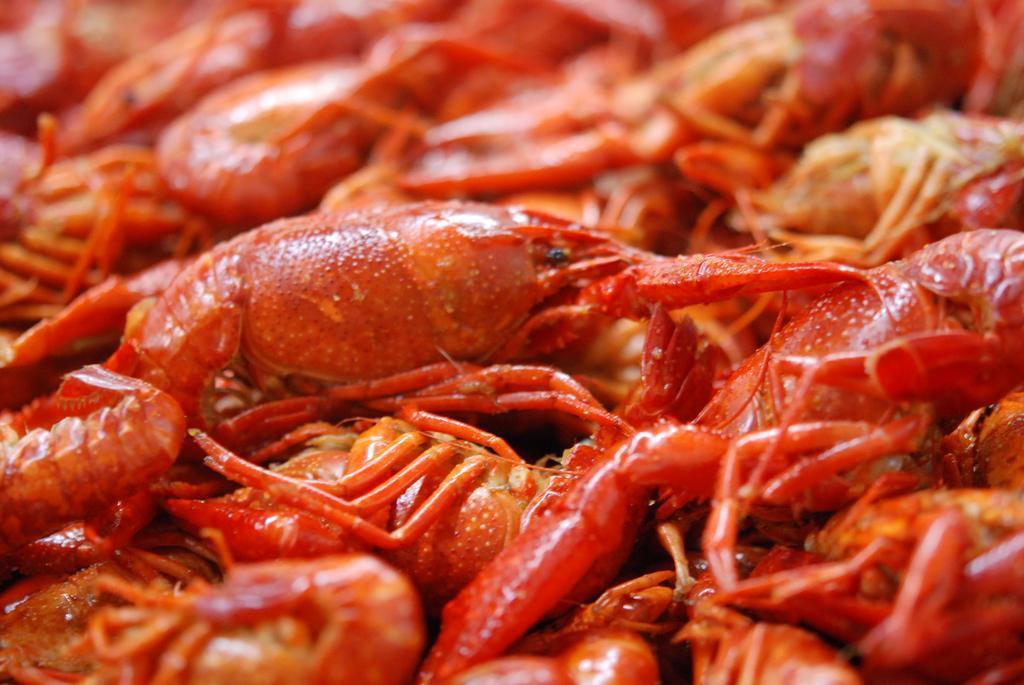Can you describe this image briefly? In this picture we can see crabs. 